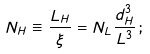Convert formula to latex. <formula><loc_0><loc_0><loc_500><loc_500>N _ { H } \equiv \frac { L _ { H } } { \xi } = N _ { L } \frac { d _ { H } ^ { 3 } } { L ^ { 3 } } \, ;</formula> 